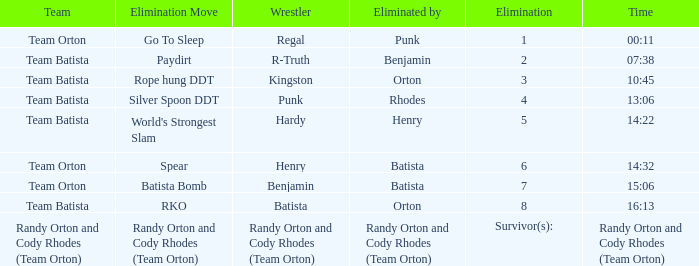What is the Elimination move listed against Regal? Go To Sleep. Can you parse all the data within this table? {'header': ['Team', 'Elimination Move', 'Wrestler', 'Eliminated by', 'Elimination', 'Time'], 'rows': [['Team Orton', 'Go To Sleep', 'Regal', 'Punk', '1', '00:11'], ['Team Batista', 'Paydirt', 'R-Truth', 'Benjamin', '2', '07:38'], ['Team Batista', 'Rope hung DDT', 'Kingston', 'Orton', '3', '10:45'], ['Team Batista', 'Silver Spoon DDT', 'Punk', 'Rhodes', '4', '13:06'], ['Team Batista', "World's Strongest Slam", 'Hardy', 'Henry', '5', '14:22'], ['Team Orton', 'Spear', 'Henry', 'Batista', '6', '14:32'], ['Team Orton', 'Batista Bomb', 'Benjamin', 'Batista', '7', '15:06'], ['Team Batista', 'RKO', 'Batista', 'Orton', '8', '16:13'], ['Randy Orton and Cody Rhodes (Team Orton)', 'Randy Orton and Cody Rhodes (Team Orton)', 'Randy Orton and Cody Rhodes (Team Orton)', 'Randy Orton and Cody Rhodes (Team Orton)', 'Survivor(s):', 'Randy Orton and Cody Rhodes (Team Orton)']]} 